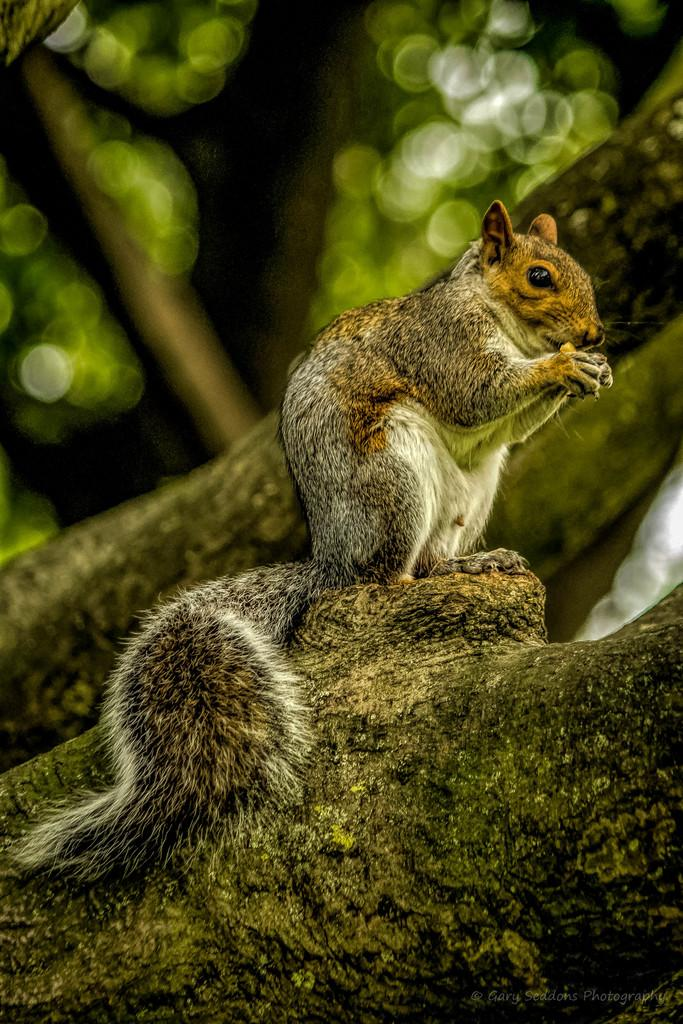What animal can be seen in the image? There is a squirrel in the image. Where is the squirrel located? The squirrel is standing on a tree log. What type of bulb is illuminating the ground in the image? There is no bulb or ground present in the image; it features a squirrel standing on a tree log. 